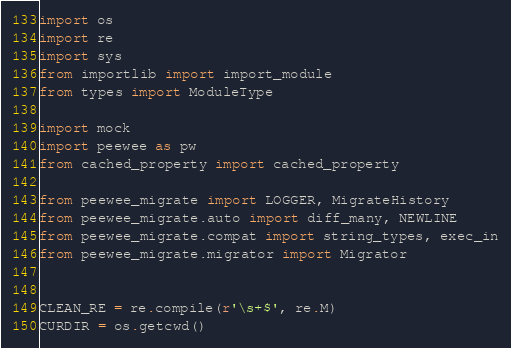Convert code to text. <code><loc_0><loc_0><loc_500><loc_500><_Python_>import os
import re
import sys
from importlib import import_module
from types import ModuleType

import mock
import peewee as pw
from cached_property import cached_property

from peewee_migrate import LOGGER, MigrateHistory
from peewee_migrate.auto import diff_many, NEWLINE
from peewee_migrate.compat import string_types, exec_in
from peewee_migrate.migrator import Migrator


CLEAN_RE = re.compile(r'\s+$', re.M)
CURDIR = os.getcwd()</code> 